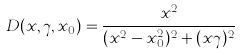<formula> <loc_0><loc_0><loc_500><loc_500>D ( x , \gamma , x _ { 0 } ) = \frac { x ^ { 2 } } { ( x ^ { 2 } - x _ { 0 } ^ { 2 } ) ^ { 2 } + ( x \gamma ) ^ { 2 } } \\</formula> 